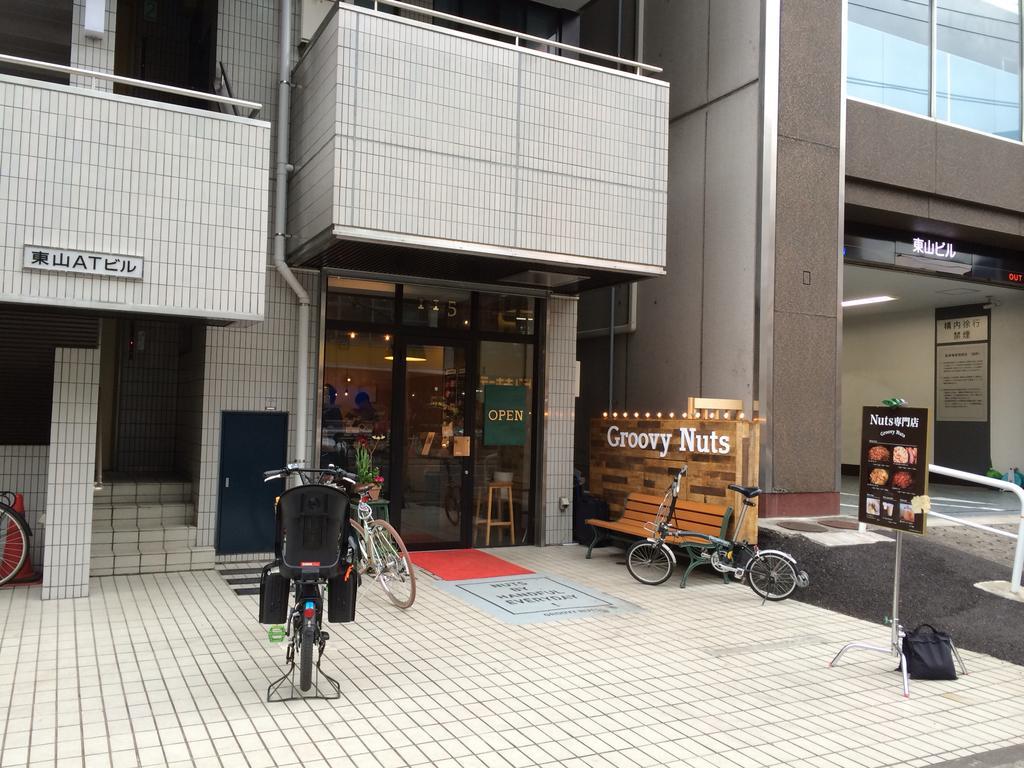Describe this image in one or two sentences. In the image there are buildings in the back with a store on the bottom with bicycles in front of it along with a bench and a banner on the right side. 